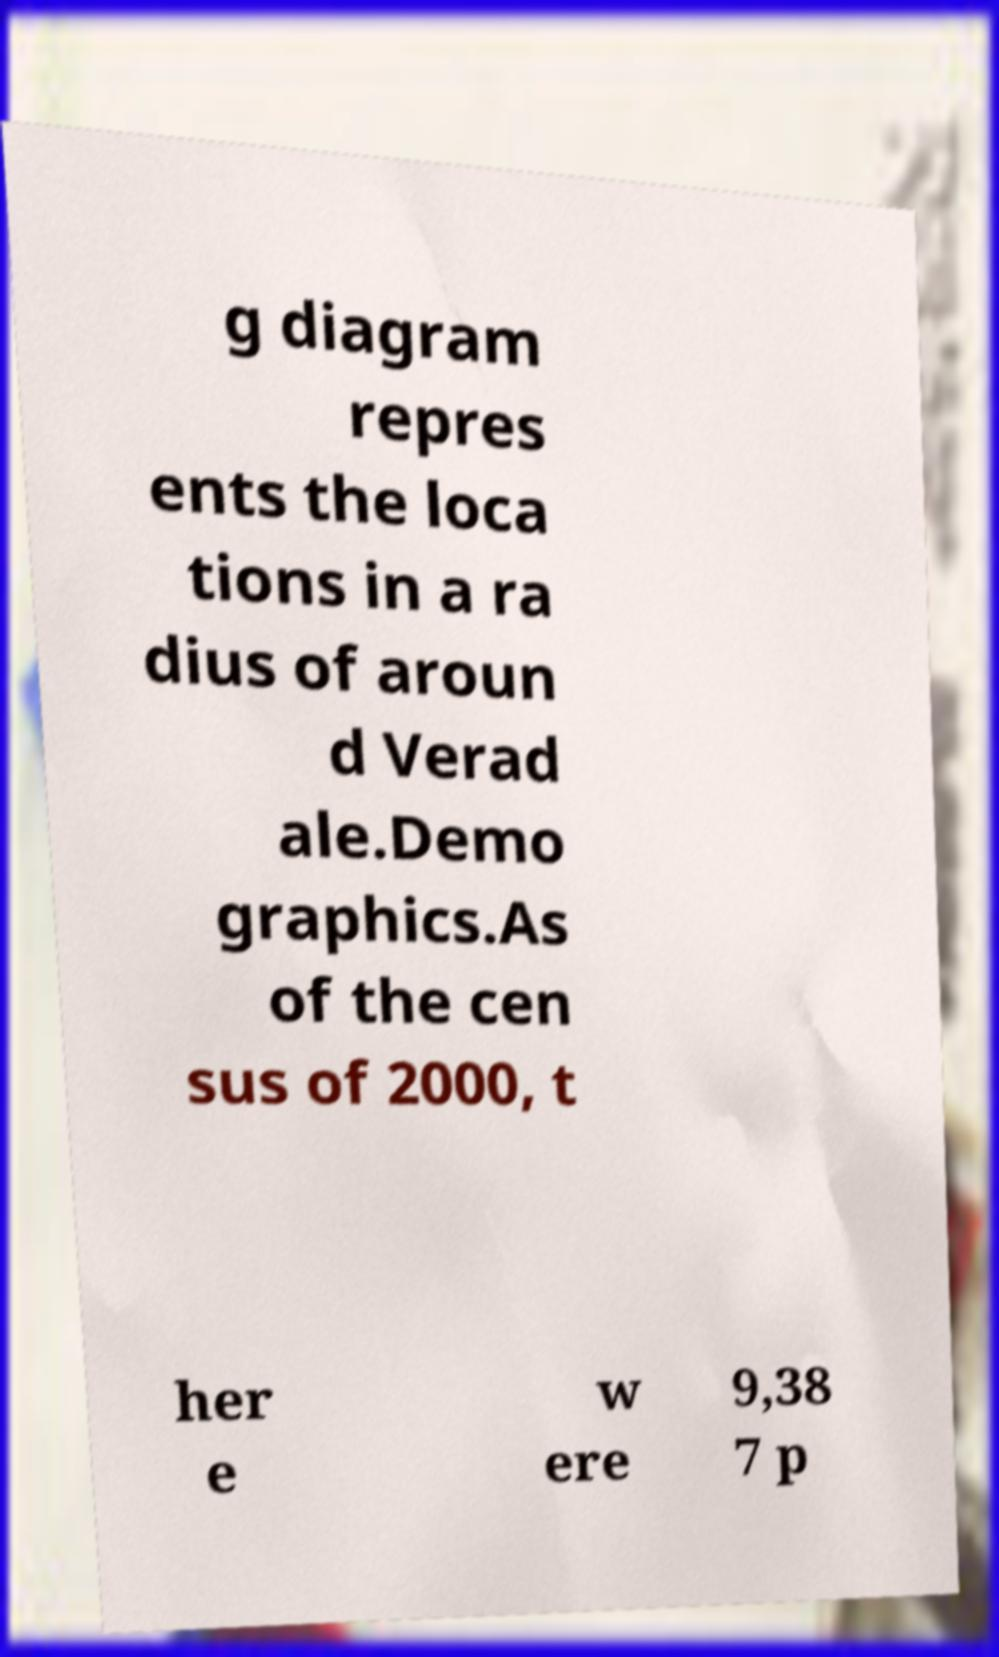Could you assist in decoding the text presented in this image and type it out clearly? g diagram repres ents the loca tions in a ra dius of aroun d Verad ale.Demo graphics.As of the cen sus of 2000, t her e w ere 9,38 7 p 